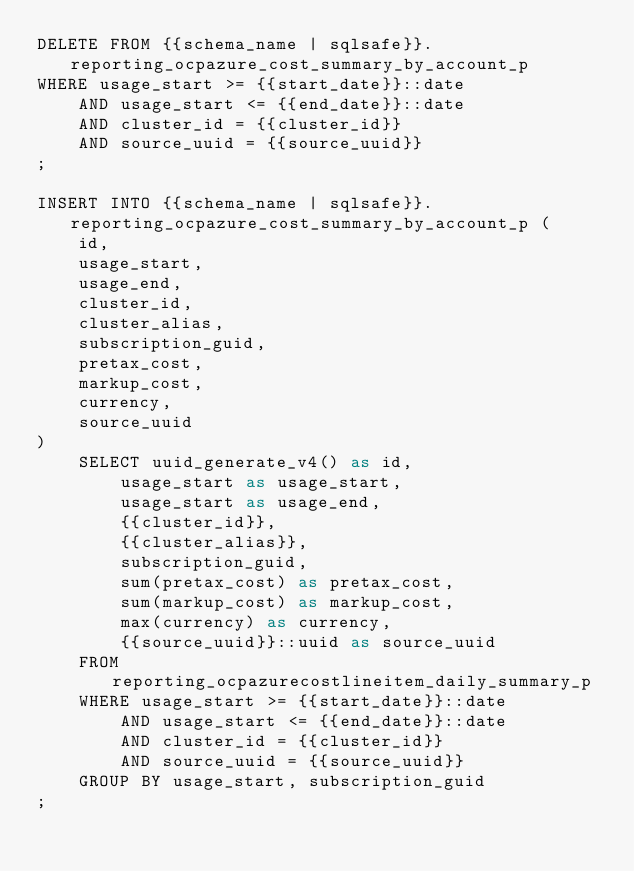<code> <loc_0><loc_0><loc_500><loc_500><_SQL_>DELETE FROM {{schema_name | sqlsafe}}.reporting_ocpazure_cost_summary_by_account_p
WHERE usage_start >= {{start_date}}::date
    AND usage_start <= {{end_date}}::date
    AND cluster_id = {{cluster_id}}
    AND source_uuid = {{source_uuid}}
;

INSERT INTO {{schema_name | sqlsafe}}.reporting_ocpazure_cost_summary_by_account_p (
    id,
    usage_start,
    usage_end,
    cluster_id,
    cluster_alias,
    subscription_guid,
    pretax_cost,
    markup_cost,
    currency,
    source_uuid
)
    SELECT uuid_generate_v4() as id,
        usage_start as usage_start,
        usage_start as usage_end,
        {{cluster_id}},
        {{cluster_alias}},
        subscription_guid,
        sum(pretax_cost) as pretax_cost,
        sum(markup_cost) as markup_cost,
        max(currency) as currency,
        {{source_uuid}}::uuid as source_uuid
    FROM reporting_ocpazurecostlineitem_daily_summary_p
    WHERE usage_start >= {{start_date}}::date
        AND usage_start <= {{end_date}}::date
        AND cluster_id = {{cluster_id}}
        AND source_uuid = {{source_uuid}}
    GROUP BY usage_start, subscription_guid
;
</code> 